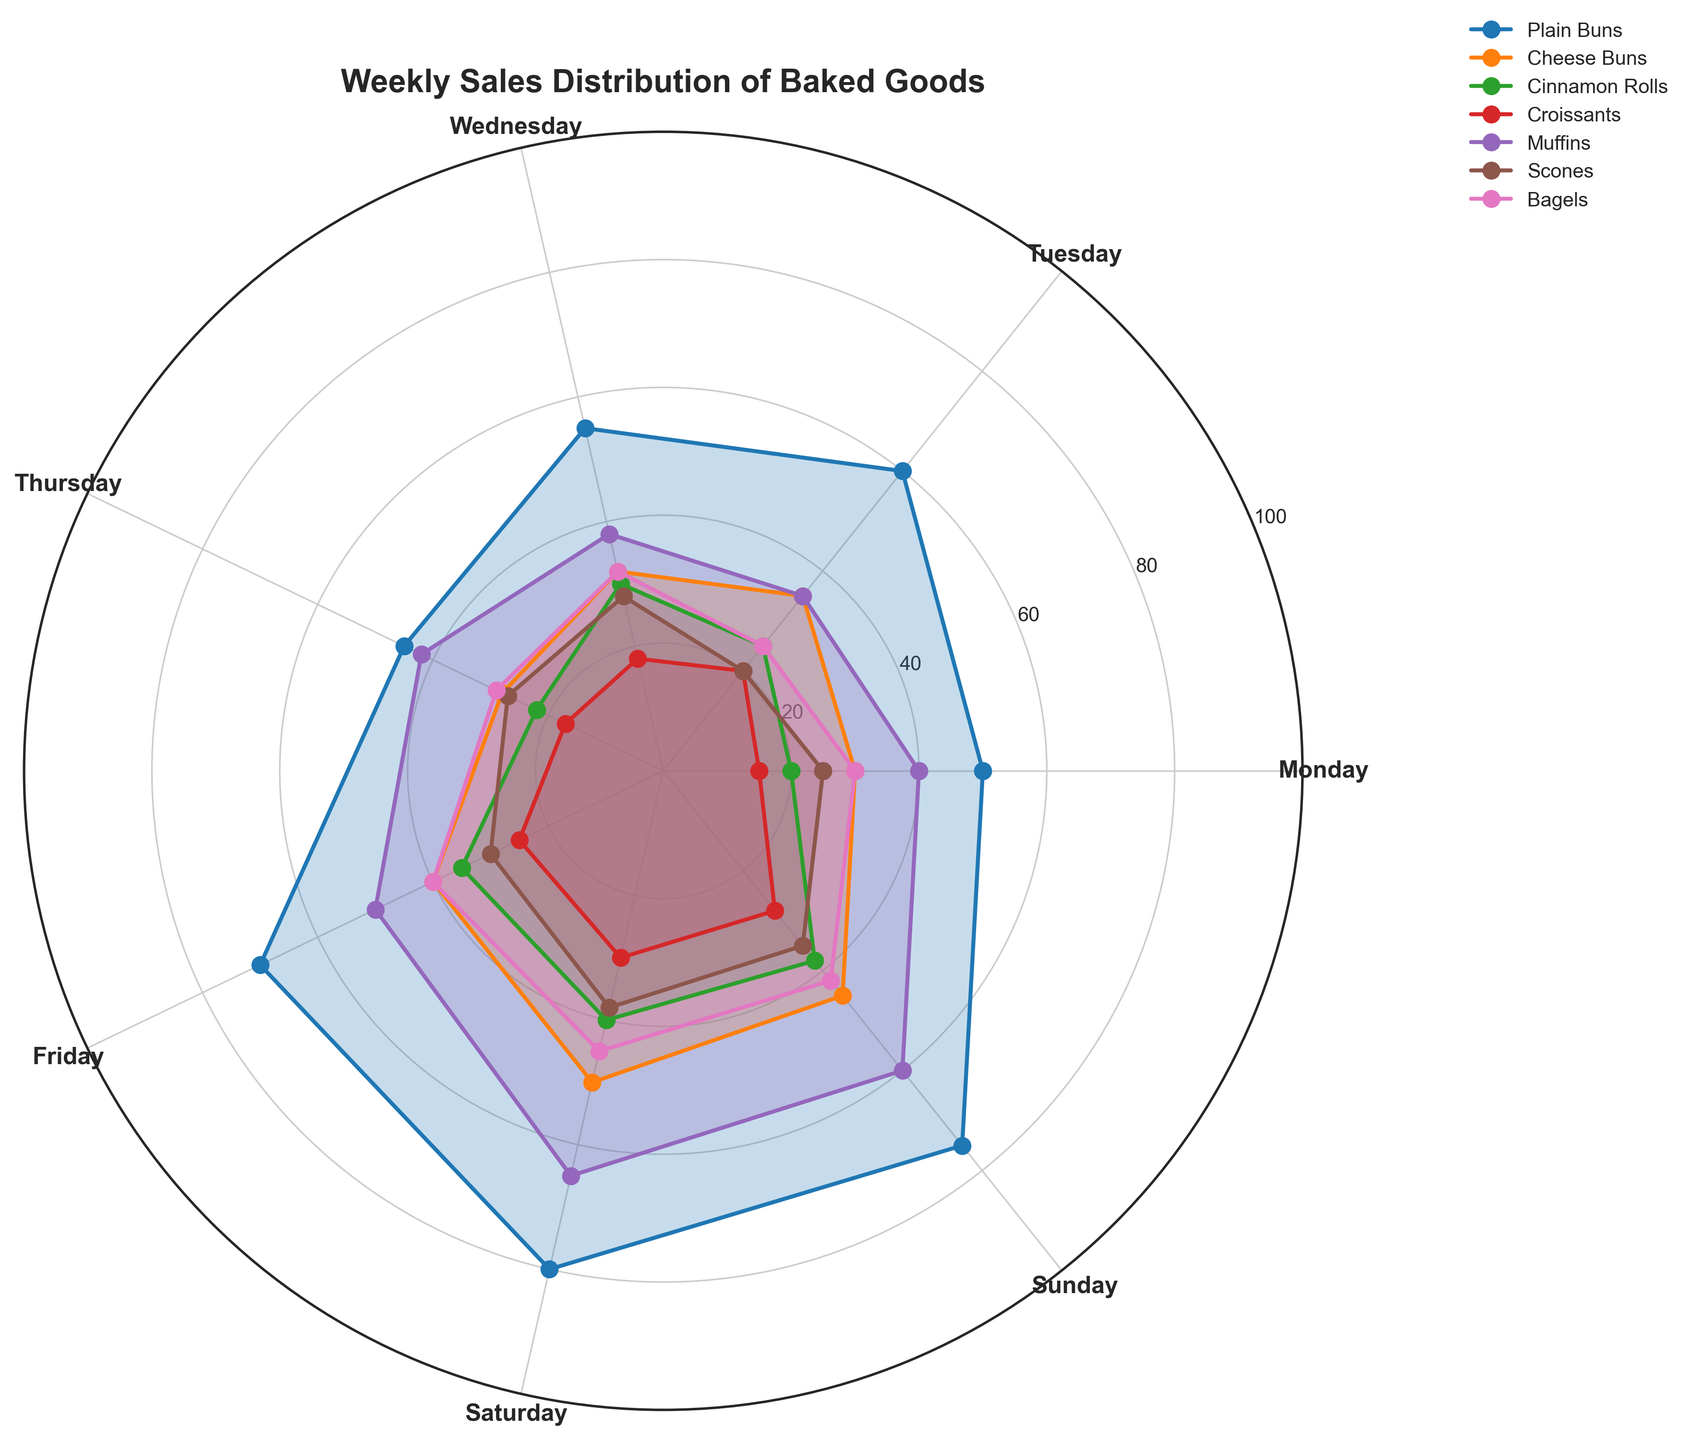What is the title of the figure? The title of the figure is prominently displayed at the top. It states the main focus of the chart, which is the sales distribution of baked goods throughout the week.
Answer: Weekly Sales Distribution of Baked Goods Which baked good had the highest sales on Saturday? By looking at the plot on Saturday and comparing the values for each baked good, we can see which one reached the highest point on the radial axis.
Answer: Plain Buns Between Tuesday and Friday, which day had higher Cinnamon Roll sales? Check the radial plot sections for Tuesday and Friday and compare the lengths of the lines corresponding to Cinnamon Rolls on these two days.
Answer: Friday How many days show the sales of Scones exceeding 20 units? Inspect each segment representing the daily sales of Scones and count the number of segments that extend beyond the 20 unit mark on the radial axis.
Answer: 7 What is the average weekly sales of Muffins? Add the sales values of Muffins for each day of the week and divide the total by 7 (the number of days in the week). (40 + 35 + 38 + 42 + 50 + 65 + 60 = 330; 330 / 7 ≈ 47.14)
Answer: 47 On which day were Bagel sales the lowest, and what was the value? Find the smallest value for Bagels by visual comparison across all days and note both the day and the value.
Answer: Tuesday, 25 Which two baked goods have the most similar sales pattern throughout the week? Compare the shapes and relative positions of the lines in the plot for each pair of baked goods to determine which pair exhibits the most similar trends across all days.
Answer: Bagels and Scones How much higher were Plain Buns sales on Sunday compared to Wednesday? Identify the values for Plain Buns on Sunday and Wednesday, then subtract the Wednesday value from the Sunday value. (75 - 55 = 20)
Answer: 20 What is the difference in sales of Croissants between the day with the highest and the day with the lowest sales? Determine the highest and lowest sales values for Croissants and find the difference between these two values. (30 - 15 = 15)
Answer: 15 Which baked goods showed a significant increase in sales from Thursday to Friday? Compare the sales values of each baked good from Thursday to Friday and identify which ones show a noticeable increase.
Answer: Cinnamon Rolls, Plain Buns, Cheese Buns, Croissants, Muffins, Bagels, Scones 